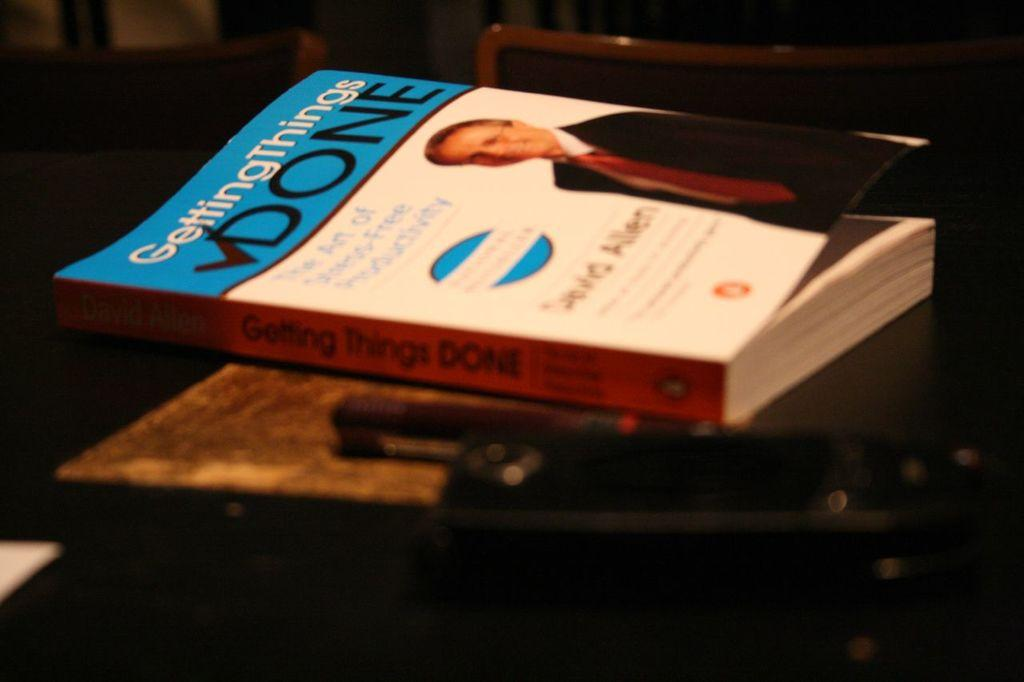<image>
Share a concise interpretation of the image provided. Gettings Things Done by Allen sits on a table 